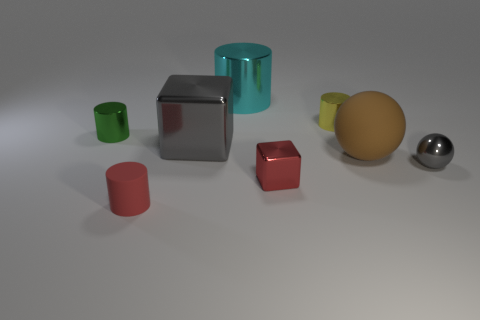Subtract all small rubber cylinders. How many cylinders are left? 3 Add 2 yellow metallic things. How many objects exist? 10 Subtract all gray spheres. How many spheres are left? 1 Subtract 4 cylinders. How many cylinders are left? 0 Subtract all balls. How many objects are left? 6 Subtract all brown spheres. How many brown cylinders are left? 0 Subtract all purple cylinders. Subtract all small cylinders. How many objects are left? 5 Add 8 cyan cylinders. How many cyan cylinders are left? 9 Add 1 tiny gray metallic spheres. How many tiny gray metallic spheres exist? 2 Subtract 1 cyan cylinders. How many objects are left? 7 